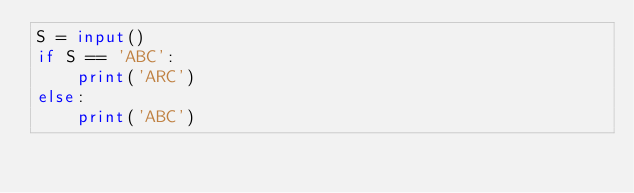<code> <loc_0><loc_0><loc_500><loc_500><_Python_>S = input()
if S == 'ABC':
    print('ARC')
else:
    print('ABC')</code> 